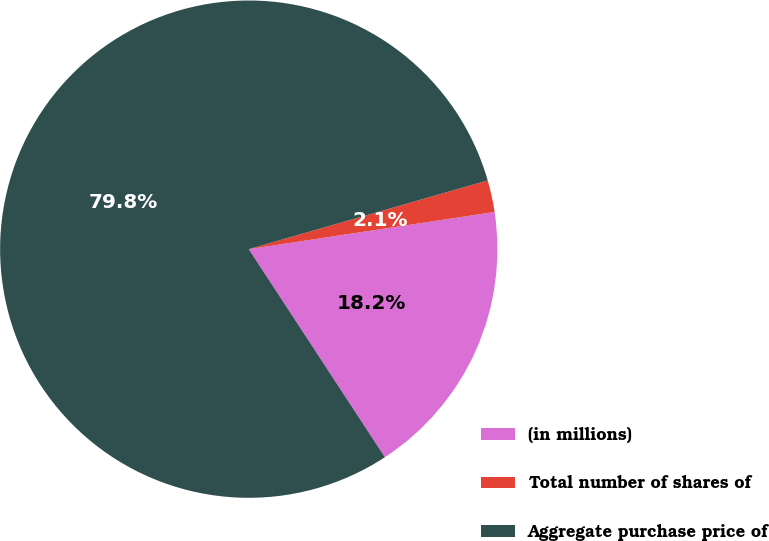Convert chart. <chart><loc_0><loc_0><loc_500><loc_500><pie_chart><fcel>(in millions)<fcel>Total number of shares of<fcel>Aggregate purchase price of<nl><fcel>18.17%<fcel>2.07%<fcel>79.76%<nl></chart> 